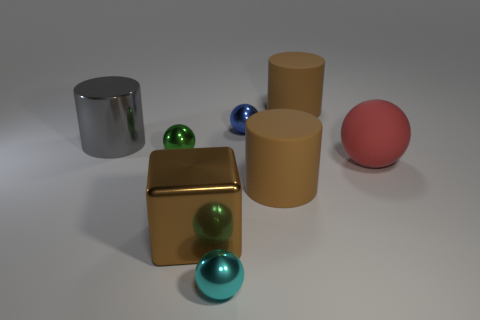Subtract all large rubber spheres. How many spheres are left? 3 Add 1 small red matte cylinders. How many objects exist? 9 Subtract all green blocks. How many brown cylinders are left? 2 Subtract 2 cylinders. How many cylinders are left? 1 Subtract all cylinders. How many objects are left? 5 Subtract all brown cylinders. How many cylinders are left? 1 Add 1 big metallic cubes. How many big metallic cubes exist? 2 Subtract 1 gray cylinders. How many objects are left? 7 Subtract all purple cubes. Subtract all red cylinders. How many cubes are left? 1 Subtract all gray cylinders. Subtract all green spheres. How many objects are left? 6 